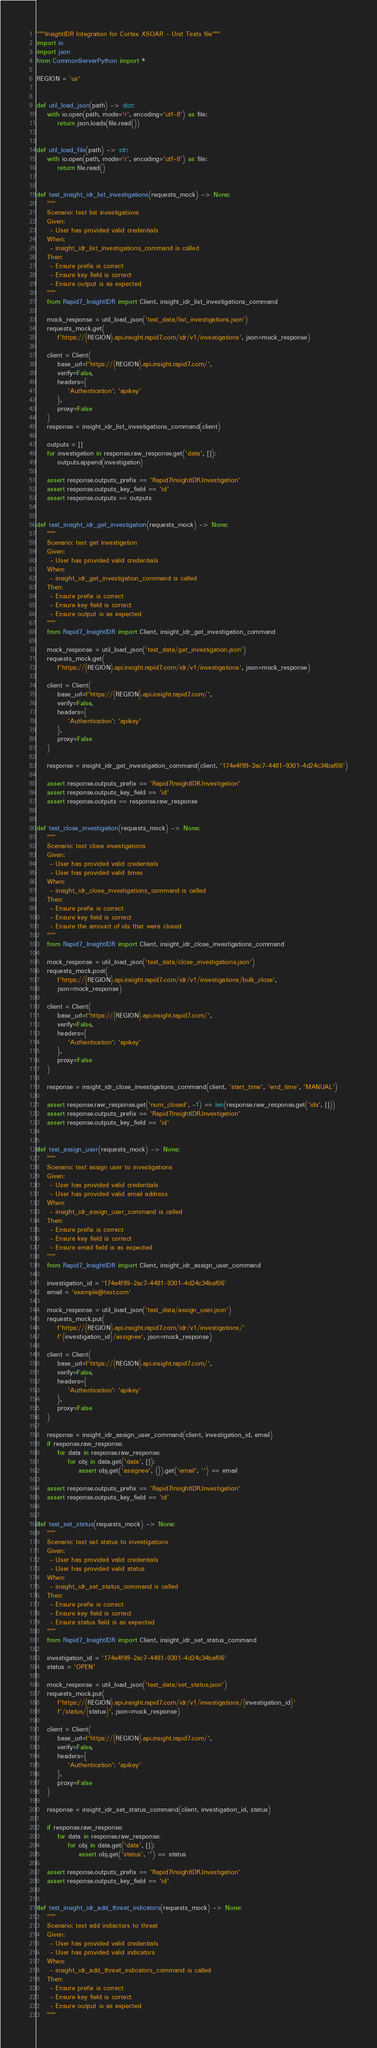<code> <loc_0><loc_0><loc_500><loc_500><_Python_>"""InsightIDR Integration for Cortex XSOAR - Unit Tests file"""
import io
import json
from CommonServerPython import *

REGION = 'us'


def util_load_json(path) -> dict:
    with io.open(path, mode='r', encoding='utf-8') as file:
        return json.loads(file.read())


def util_load_file(path) -> str:
    with io.open(path, mode='r', encoding='utf-8') as file:
        return file.read()


def test_insight_idr_list_investigations(requests_mock) -> None:
    """
    Scenario: test list investigations
    Given:
     - User has provided valid credentials
    When:
     - insight_idr_list_investigations_command is called
    Then:
     - Ensure prefix is correct
     - Ensure key field is correct
     - Ensure output is as expected
    """
    from Rapid7_InsightIDR import Client, insight_idr_list_investigations_command

    mock_response = util_load_json('test_data/list_investigations.json')
    requests_mock.get(
        f'https://{REGION}.api.insight.rapid7.com/idr/v1/investigations', json=mock_response)

    client = Client(
        base_url=f'https://{REGION}.api.insight.rapid7.com/',
        verify=False,
        headers={
            'Authentication': 'apikey'
        },
        proxy=False
    )
    response = insight_idr_list_investigations_command(client)

    outputs = []
    for investigation in response.raw_response.get('data', []):
        outputs.append(investigation)

    assert response.outputs_prefix == 'Rapid7InsightIDR.Investigation'
    assert response.outputs_key_field == 'id'
    assert response.outputs == outputs


def test_insight_idr_get_investigation(requests_mock) -> None:
    """
    Scenario: test get investigation
    Given:
     - User has provided valid credentials
    When:
     - insight_idr_get_investigation_command is called
    Then:
     - Ensure prefix is correct
     - Ensure key field is correct
     - Ensure output is as expected
    """
    from Rapid7_InsightIDR import Client, insight_idr_get_investigation_command

    mock_response = util_load_json('test_data/get_investigation.json')
    requests_mock.get(
        f'https://{REGION}.api.insight.rapid7.com/idr/v1/investigations', json=mock_response)

    client = Client(
        base_url=f'https://{REGION}.api.insight.rapid7.com/',
        verify=False,
        headers={
            'Authentication': 'apikey'
        },
        proxy=False
    )

    response = insight_idr_get_investigation_command(client, '174e4f99-2ac7-4481-9301-4d24c34baf06')

    assert response.outputs_prefix == 'Rapid7InsightIDR.Investigation'
    assert response.outputs_key_field == 'id'
    assert response.outputs == response.raw_response


def test_close_investigation(requests_mock) -> None:
    """
    Scenario: test close investigations
    Given:
     - User has provided valid credentials
     - User has provided valid times
    When:
     - insight_idr_close_investigations_command is called
    Then:
     - Ensure prefix is correct
     - Ensure key field is correct
     - Ensure the amount of ids that were closed
    """
    from Rapid7_InsightIDR import Client, insight_idr_close_investigations_command

    mock_response = util_load_json('test_data/close_investigations.json')
    requests_mock.post(
        f'https://{REGION}.api.insight.rapid7.com/idr/v1/investigations/bulk_close',
        json=mock_response)

    client = Client(
        base_url=f'https://{REGION}.api.insight.rapid7.com/',
        verify=False,
        headers={
            'Authentication': 'apikey'
        },
        proxy=False
    )

    response = insight_idr_close_investigations_command(client, 'start_time', 'end_time', 'MANUAL')

    assert response.raw_response.get('num_closed', -1) == len(response.raw_response.get('ids', []))
    assert response.outputs_prefix == 'Rapid7InsightIDR.Investigation'
    assert response.outputs_key_field == 'id'


def test_assign_user(requests_mock) -> None:
    """
    Scenario: test assign user to investigations
    Given:
     - User has provided valid credentials
     - User has provided valid email address
    When:
     - insight_idr_assign_user_command is called
    Then:
     - Ensure prefix is correct
     - Ensure key field is correct
     - Ensure email field is as expected
    """
    from Rapid7_InsightIDR import Client, insight_idr_assign_user_command

    investigation_id = '174e4f99-2ac7-4481-9301-4d24c34baf06'
    email = 'example@test.com'

    mock_response = util_load_json('test_data/assign_user.json')
    requests_mock.put(
        f'https://{REGION}.api.insight.rapid7.com/idr/v1/investigations/'
        f'{investigation_id}/assignee', json=mock_response)

    client = Client(
        base_url=f'https://{REGION}.api.insight.rapid7.com/',
        verify=False,
        headers={
            'Authentication': 'apikey'
        },
        proxy=False
    )

    response = insight_idr_assign_user_command(client, investigation_id, email)
    if response.raw_response:
        for data in response.raw_response:
            for obj in data.get('data', []):
                assert obj.get('assignee', {}).get('email', '') == email

    assert response.outputs_prefix == 'Rapid7InsightIDR.Investigation'
    assert response.outputs_key_field == 'id'


def test_set_status(requests_mock) -> None:
    """
    Scenario: test set status to investigations
    Given:
     - User has provided valid credentials
     - User has provided valid status
    When:
     - insight_idr_set_status_command is called
    Then:
     - Ensure prefix is correct
     - Ensure key field is correct
     - Ensure status field is as expected
    """
    from Rapid7_InsightIDR import Client, insight_idr_set_status_command

    investigation_id = '174e4f99-2ac7-4481-9301-4d24c34baf06'
    status = 'OPEN'

    mock_response = util_load_json('test_data/set_status.json')
    requests_mock.put(
        f'https://{REGION}.api.insight.rapid7.com/idr/v1/investigations/{investigation_id}'
        f'/status/{status}', json=mock_response)

    client = Client(
        base_url=f'https://{REGION}.api.insight.rapid7.com/',
        verify=False,
        headers={
            'Authentication': 'apikey'
        },
        proxy=False
    )

    response = insight_idr_set_status_command(client, investigation_id, status)

    if response.raw_response:
        for data in response.raw_response:
            for obj in data.get('data', []):
                assert obj.get('status', '') == status

    assert response.outputs_prefix == 'Rapid7InsightIDR.Investigation'
    assert response.outputs_key_field == 'id'


def test_insight_idr_add_threat_indicators(requests_mock) -> None:
    """
    Scenario: test add indiactors to threat
    Given:
     - User has provided valid credentials
     - User has provided valid indicators
    When:
     - insight_idr_add_threat_indicators_command is called
    Then:
     - Ensure prefix is correct
     - Ensure key field is correct
     - Ensure output is as expected
    """</code> 